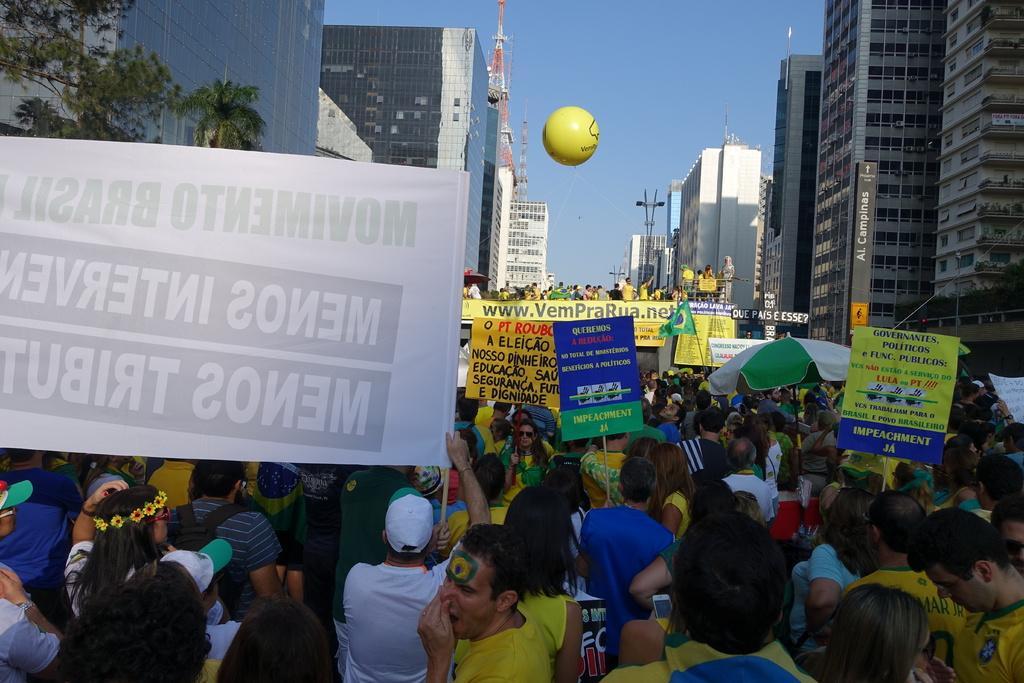In one or two sentences, can you explain what this image depicts? In this image I can see number of people are standing and holding banners in their hands. In the background I can see few buildings, a tree, a tower which is white and red in color, a balloon which is yellow in color, few persons standing on a bridge and the sky. 